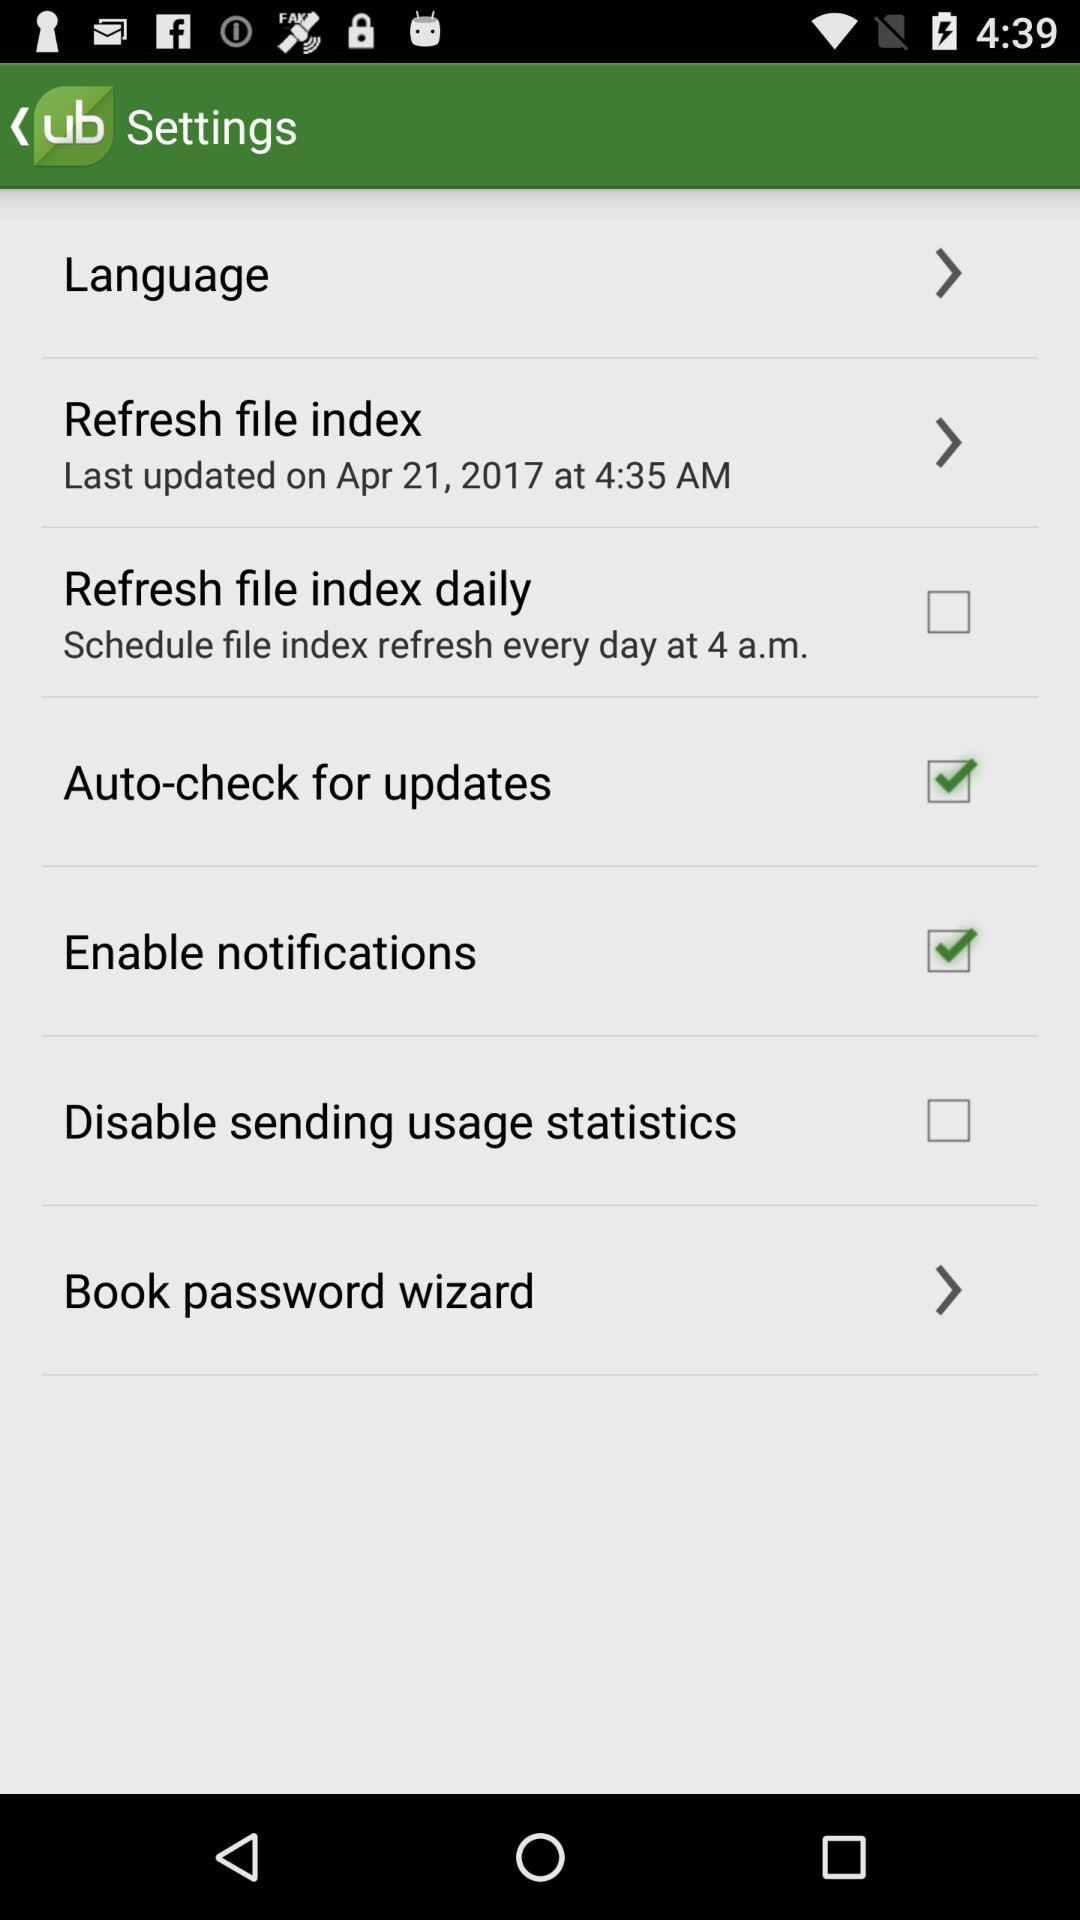When was the refresh file index last updated? The refresh file index was last updated on April 21, 2017 at 4:35 AM. 